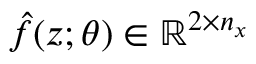Convert formula to latex. <formula><loc_0><loc_0><loc_500><loc_500>\hat { f } ( z ; \theta ) \in \mathbb { R } ^ { 2 \times n _ { x } }</formula> 